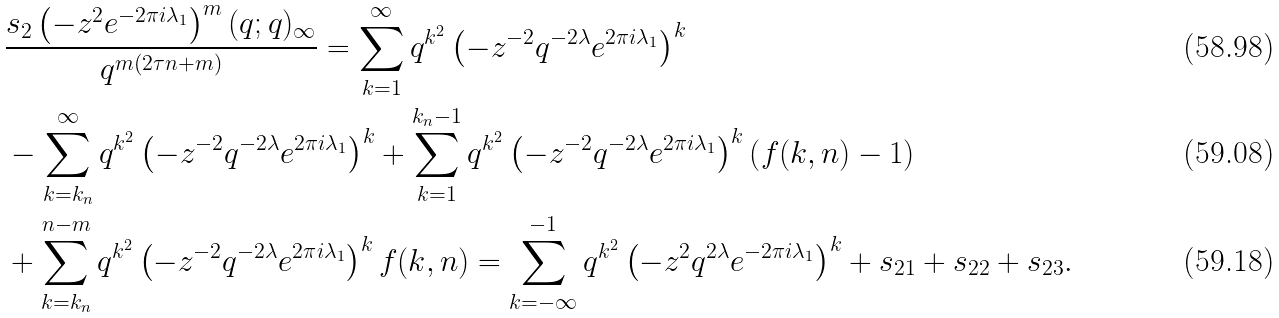<formula> <loc_0><loc_0><loc_500><loc_500>& \frac { s _ { 2 } \left ( - z ^ { 2 } e ^ { - 2 \pi i \lambda _ { 1 } } \right ) ^ { m } ( q ; q ) _ { \infty } } { q ^ { m \left ( 2 \tau n + m \right ) } } = \sum _ { k = 1 } ^ { \infty } q ^ { k ^ { 2 } } \left ( - z ^ { - 2 } q ^ { - 2 \lambda } e ^ { 2 \pi i \lambda _ { 1 } } \right ) ^ { k } \\ & - \sum _ { k = k _ { n } } ^ { \infty } q ^ { k ^ { 2 } } \left ( - z ^ { - 2 } q ^ { - 2 \lambda } e ^ { 2 \pi i \lambda _ { 1 } } \right ) ^ { k } + \sum _ { k = 1 } ^ { k _ { n } - 1 } q ^ { k ^ { 2 } } \left ( - z ^ { - 2 } q ^ { - 2 \lambda } e ^ { 2 \pi i \lambda _ { 1 } } \right ) ^ { k } \left ( f ( k , n ) - 1 \right ) \\ & + \sum _ { k = k _ { n } } ^ { n - m } q ^ { k ^ { 2 } } \left ( - z ^ { - 2 } q ^ { - 2 \lambda } e ^ { 2 \pi i \lambda _ { 1 } } \right ) ^ { k } f ( k , n ) = \sum _ { k = - \infty } ^ { - 1 } q ^ { k ^ { 2 } } \left ( - z ^ { 2 } q ^ { 2 \lambda } e ^ { - 2 \pi i \lambda _ { 1 } } \right ) ^ { k } + s _ { 2 1 } + s _ { 2 2 } + s _ { 2 3 } .</formula> 